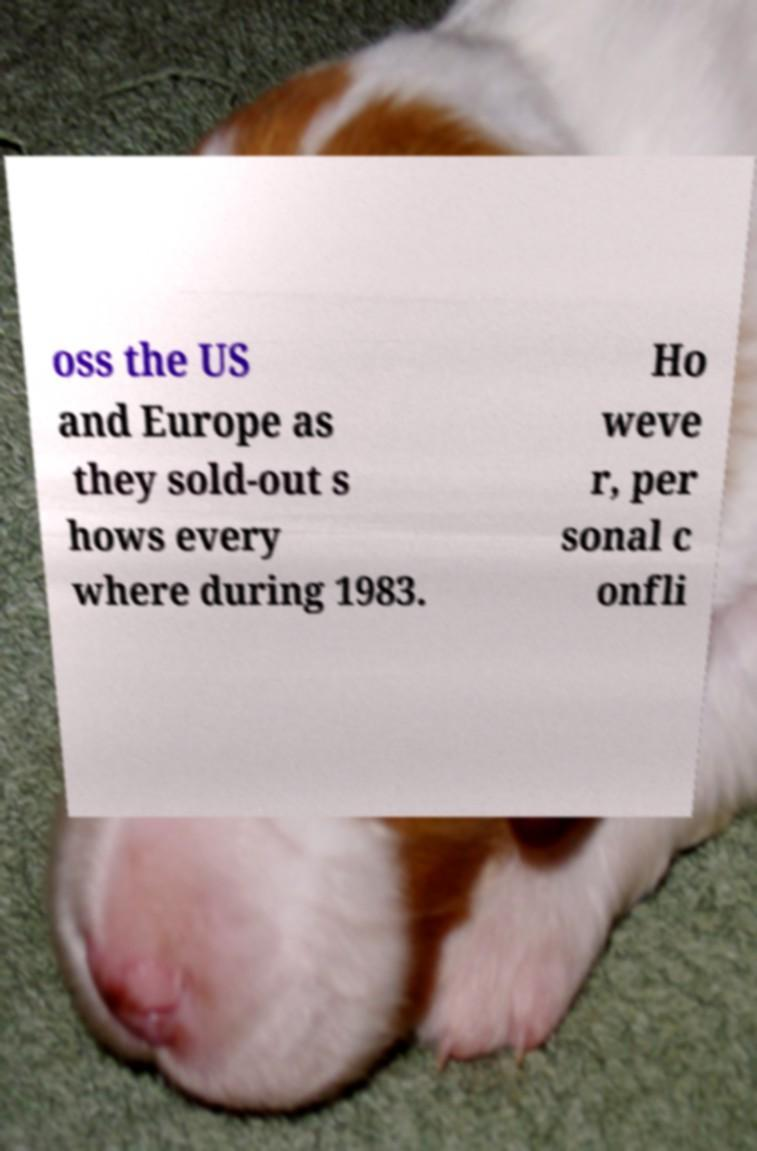Could you extract and type out the text from this image? oss the US and Europe as they sold-out s hows every where during 1983. Ho weve r, per sonal c onfli 